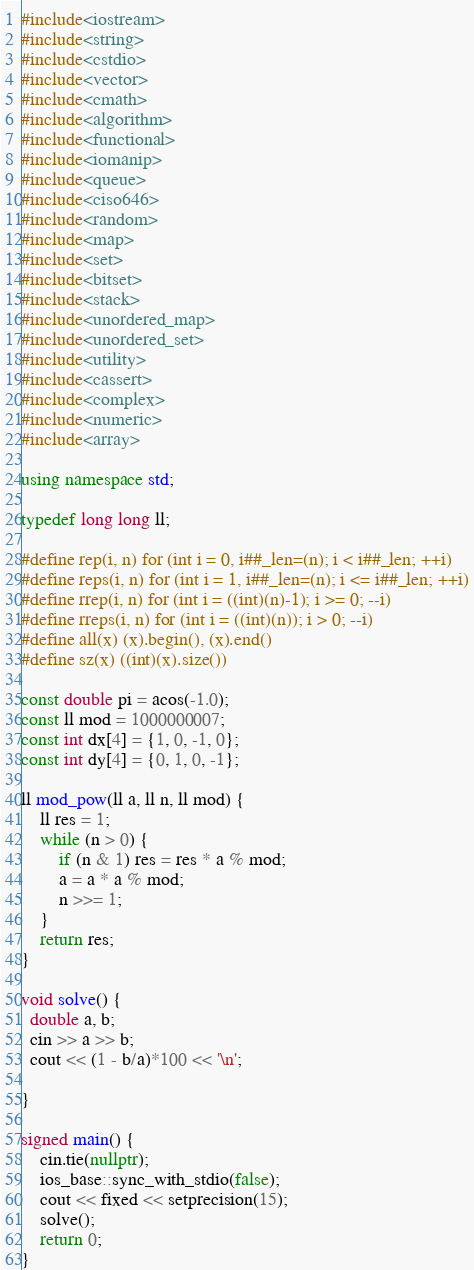<code> <loc_0><loc_0><loc_500><loc_500><_C++_>#include<iostream>
#include<string>
#include<cstdio>
#include<vector>
#include<cmath>
#include<algorithm>
#include<functional>
#include<iomanip>
#include<queue>
#include<ciso646>
#include<random>
#include<map>
#include<set>
#include<bitset>
#include<stack>
#include<unordered_map>
#include<unordered_set>
#include<utility>
#include<cassert>
#include<complex>
#include<numeric>
#include<array>

using namespace std;

typedef long long ll;

#define rep(i, n) for (int i = 0, i##_len=(n); i < i##_len; ++i)
#define reps(i, n) for (int i = 1, i##_len=(n); i <= i##_len; ++i)
#define rrep(i, n) for (int i = ((int)(n)-1); i >= 0; --i)
#define rreps(i, n) for (int i = ((int)(n)); i > 0; --i)
#define all(x) (x).begin(), (x).end()
#define sz(x) ((int)(x).size())

const double pi = acos(-1.0);
const ll mod = 1000000007;
const int dx[4] = {1, 0, -1, 0};
const int dy[4] = {0, 1, 0, -1};

ll mod_pow(ll a, ll n, ll mod) {
    ll res = 1;
    while (n > 0) {
        if (n & 1) res = res * a % mod;
        a = a * a % mod;
        n >>= 1;
    }
    return res;
}

void solve() {
  double a, b;
  cin >> a >> b;
  cout << (1 - b/a)*100 << '\n';

}

signed main() {
    cin.tie(nullptr);
    ios_base::sync_with_stdio(false);
    cout << fixed << setprecision(15);
    solve();
    return 0;
}
</code> 